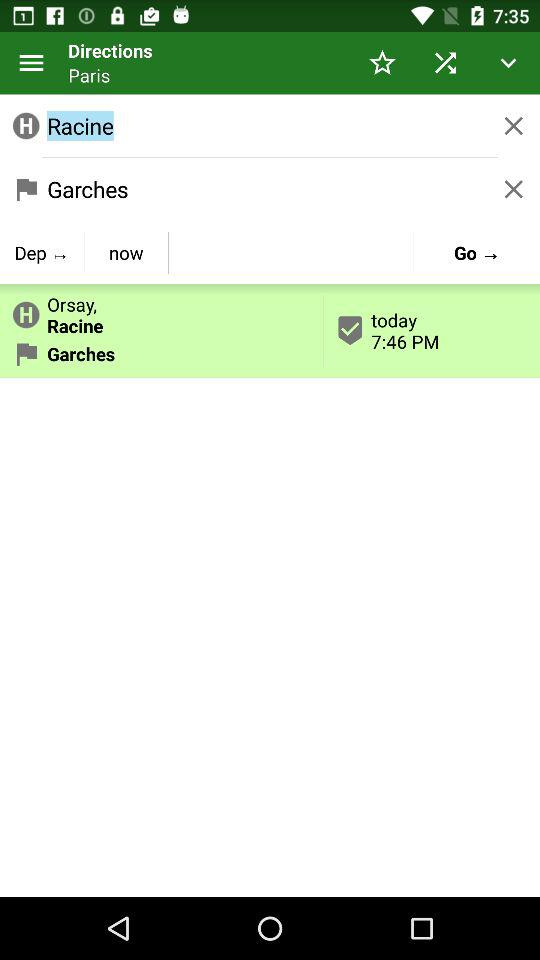What is the departure location? The departure location is Racine. 